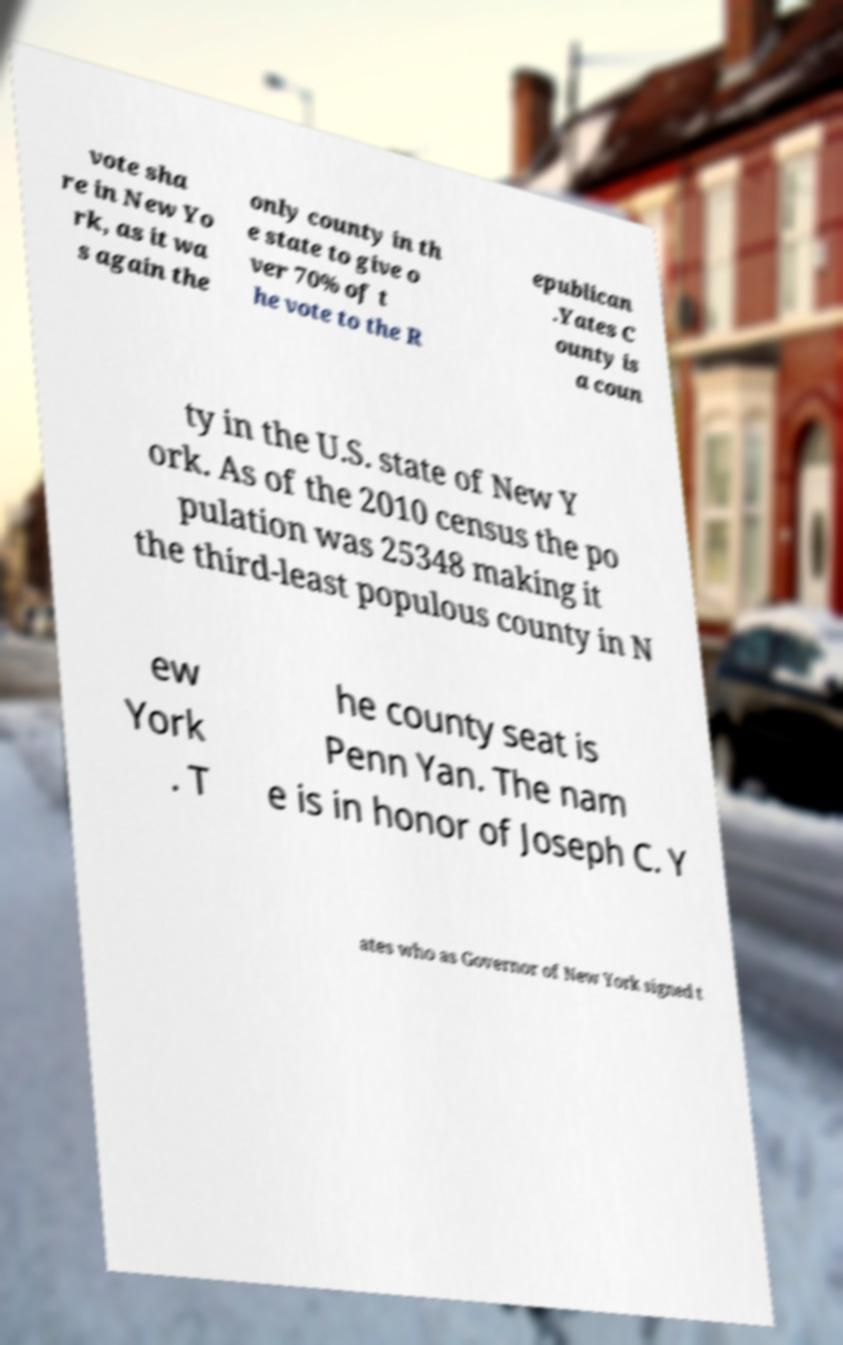Could you extract and type out the text from this image? vote sha re in New Yo rk, as it wa s again the only county in th e state to give o ver 70% of t he vote to the R epublican .Yates C ounty is a coun ty in the U.S. state of New Y ork. As of the 2010 census the po pulation was 25348 making it the third-least populous county in N ew York . T he county seat is Penn Yan. The nam e is in honor of Joseph C. Y ates who as Governor of New York signed t 